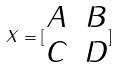Convert formula to latex. <formula><loc_0><loc_0><loc_500><loc_500>X = [ \begin{matrix} A & B \\ C & D \end{matrix} ]</formula> 